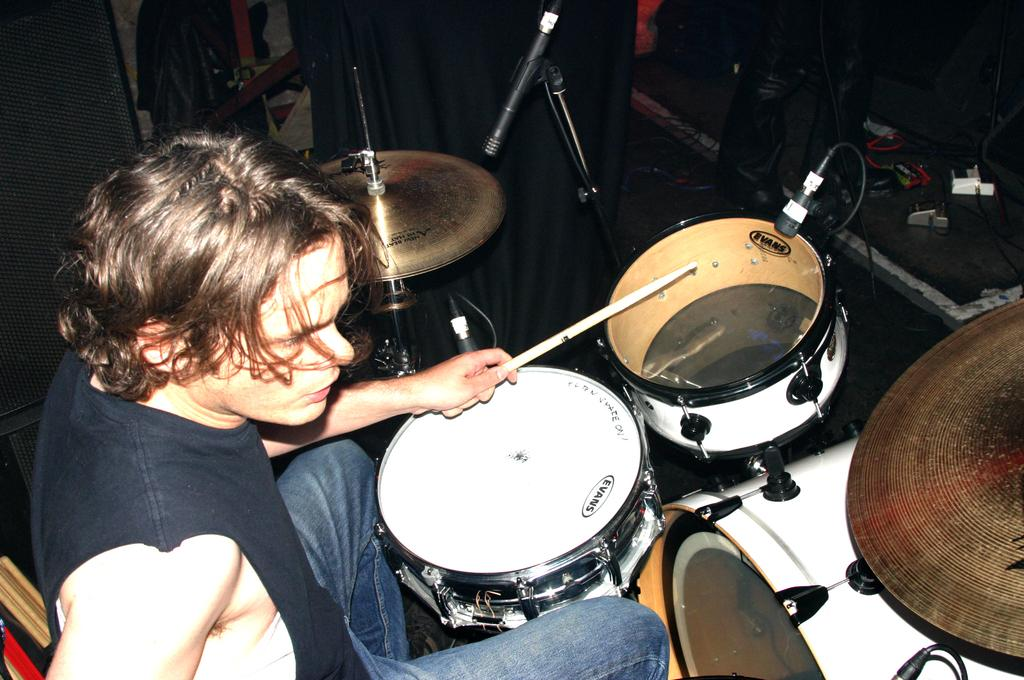What is the man in the image doing? The man is sitting and playing drums. What instruments can be seen in the image? There are drums and cymbals in the image. What equipment is present for amplifying sound? There are microphones in the image. What can be seen in the background of the image? There are wires in the background of the image. What type of jam is being served in the image? There is no jam present in the image; it features a man playing drums with cymbals, microphones, and wires in the background. What kind of flowers are on the table in the image? There is no table or flowers present in the image; it features a man playing drums with cymbals, microphones, and wires in the background. 